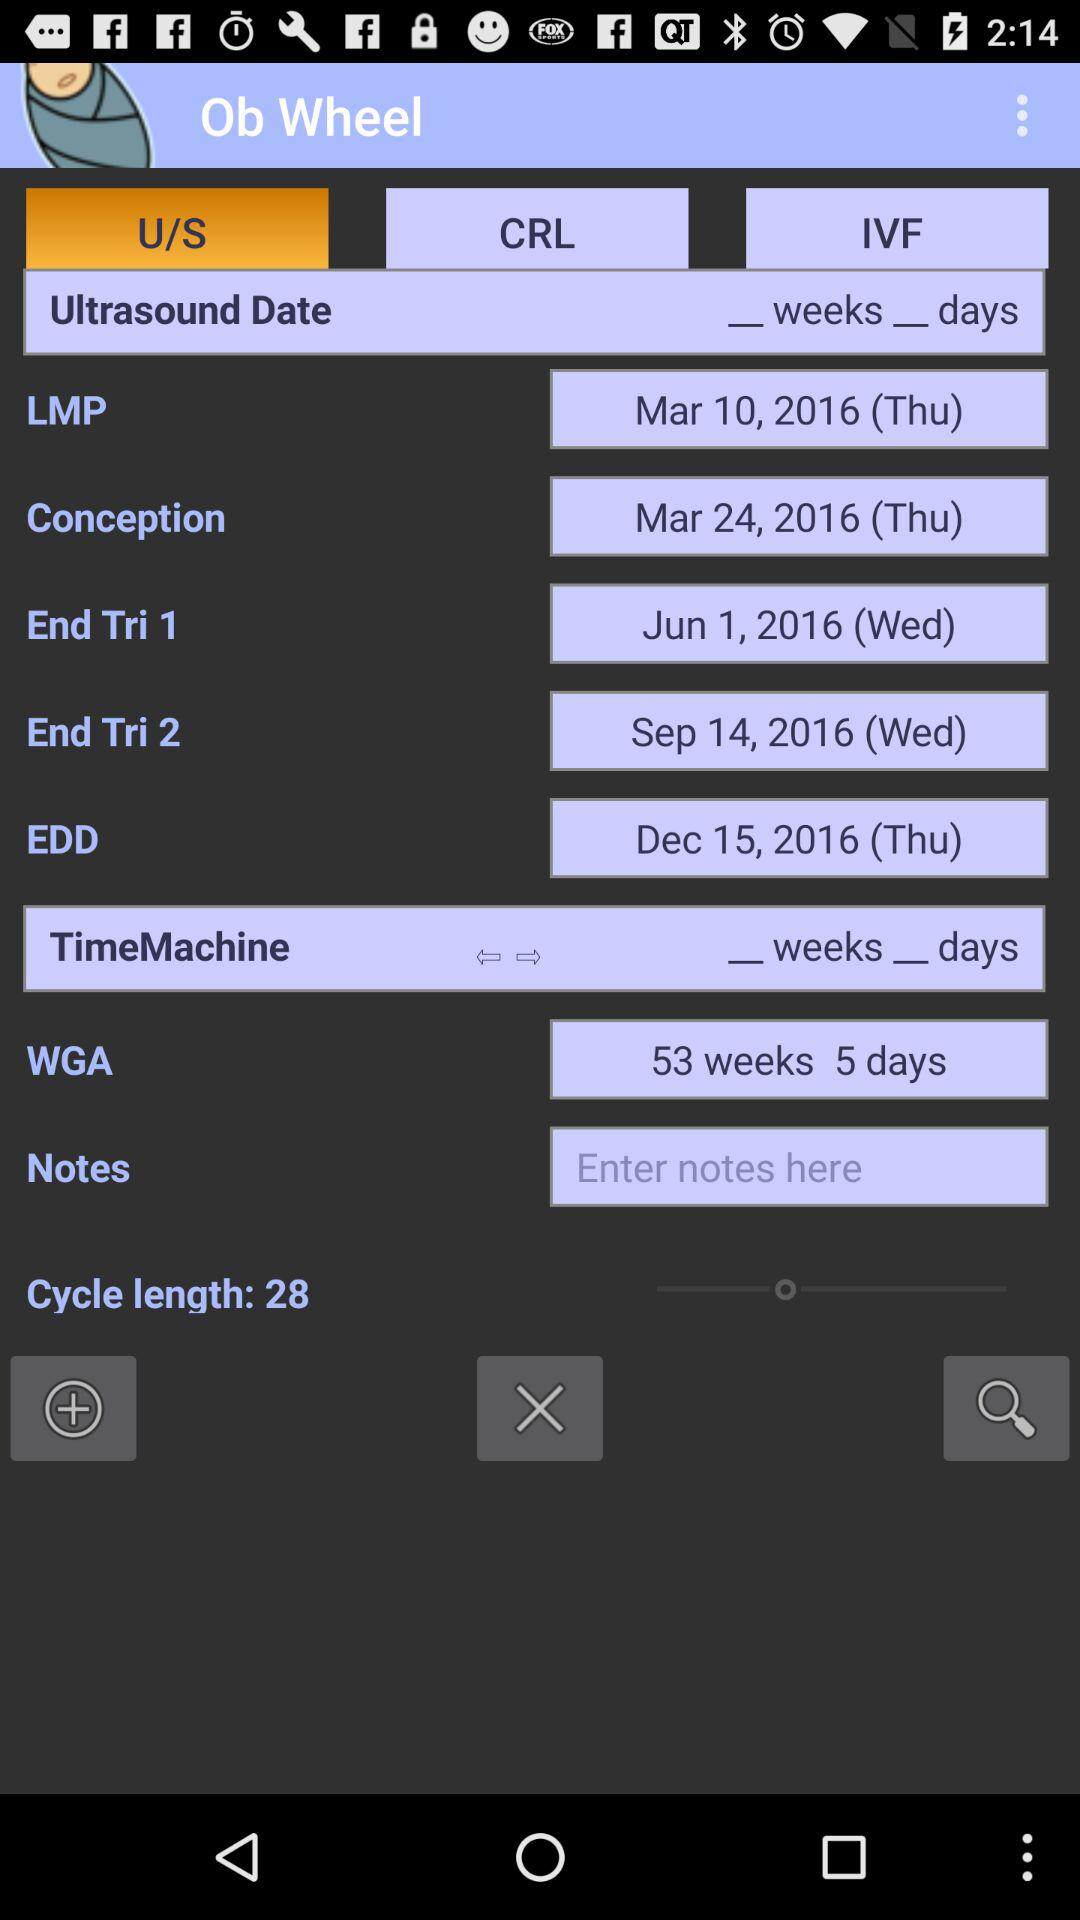Which tab is selected? The selected tab is "U/S". 